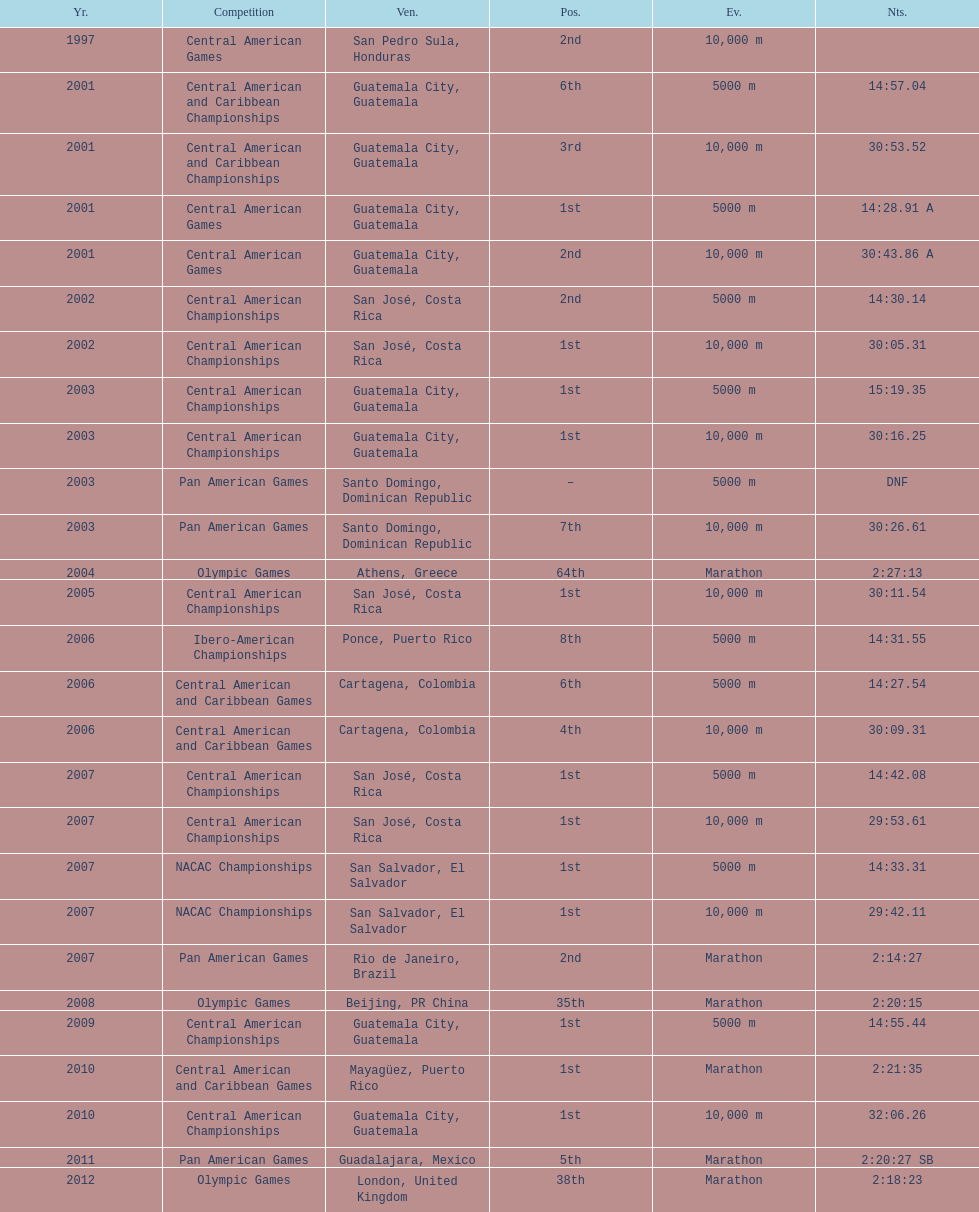Where was the only 64th position held? Athens, Greece. 